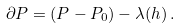<formula> <loc_0><loc_0><loc_500><loc_500>\partial P = ( P - P _ { 0 } ) - \lambda ( h ) \, .</formula> 